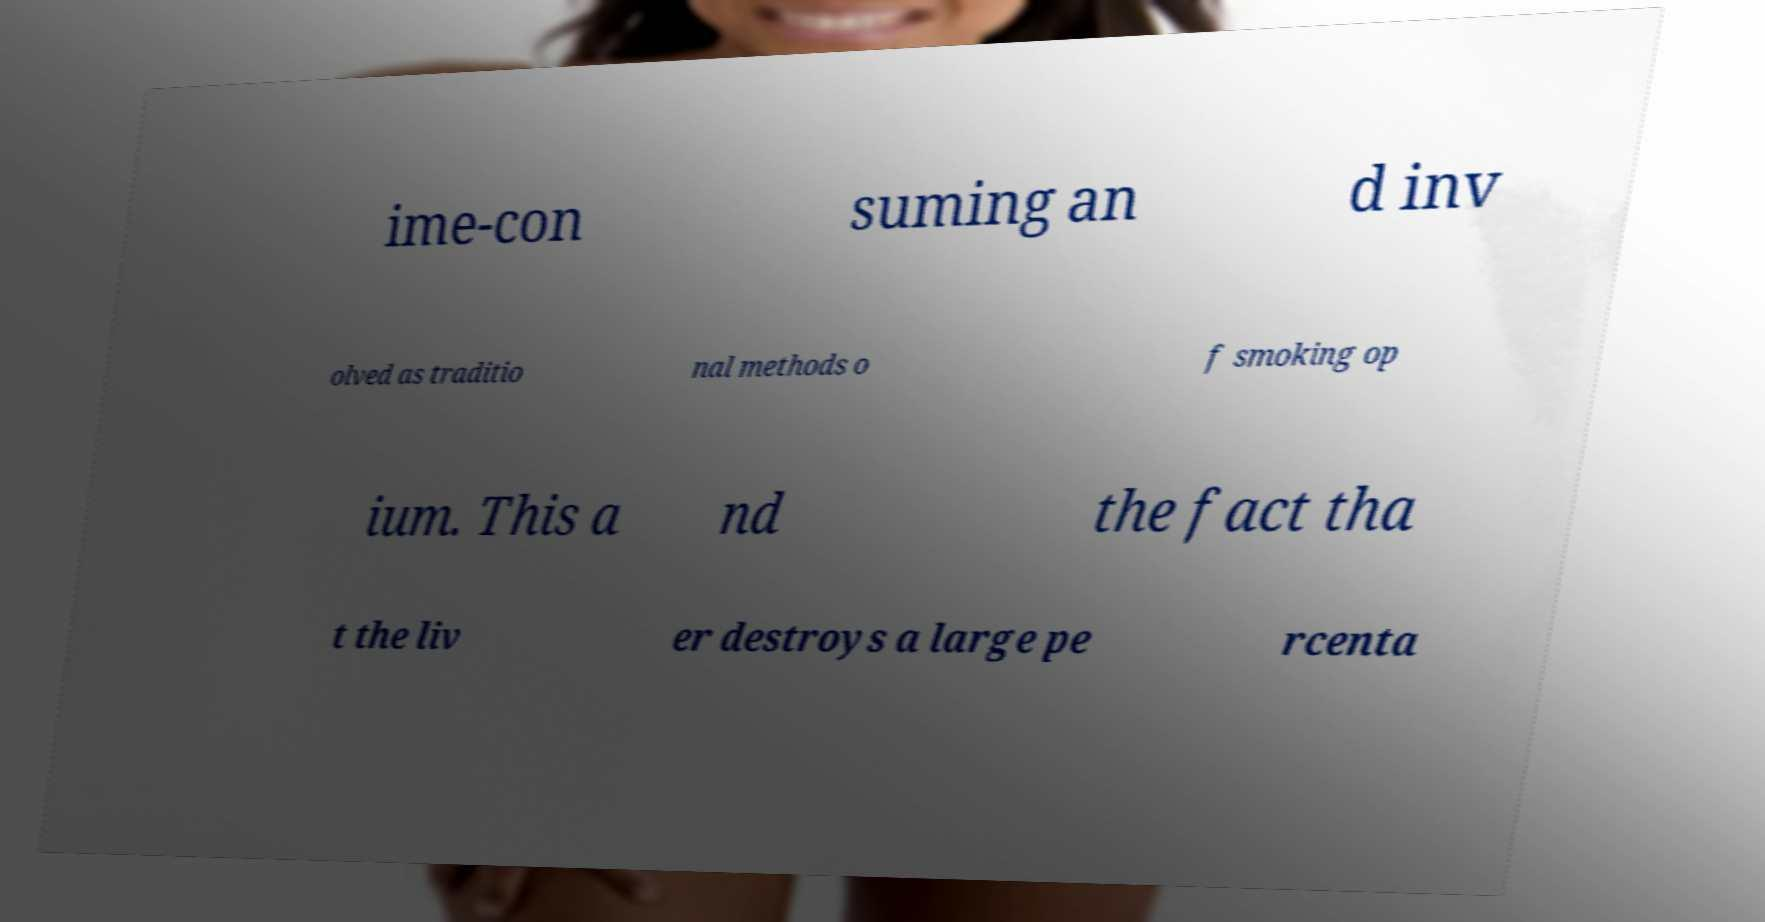Can you accurately transcribe the text from the provided image for me? ime-con suming an d inv olved as traditio nal methods o f smoking op ium. This a nd the fact tha t the liv er destroys a large pe rcenta 